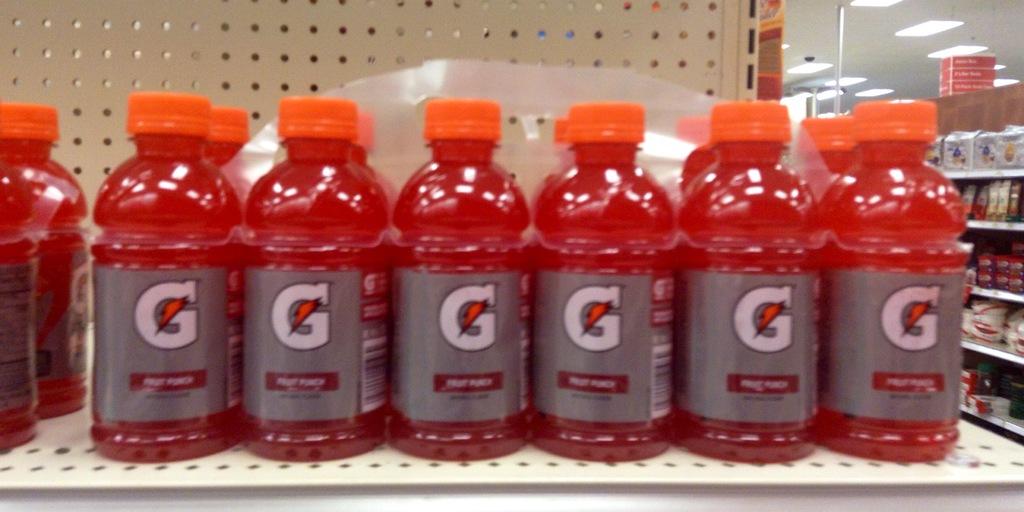What kind of beverage is this?
Your response must be concise. Fruit punch. What flavor is this beverage?
Offer a terse response. Fruit punch. 